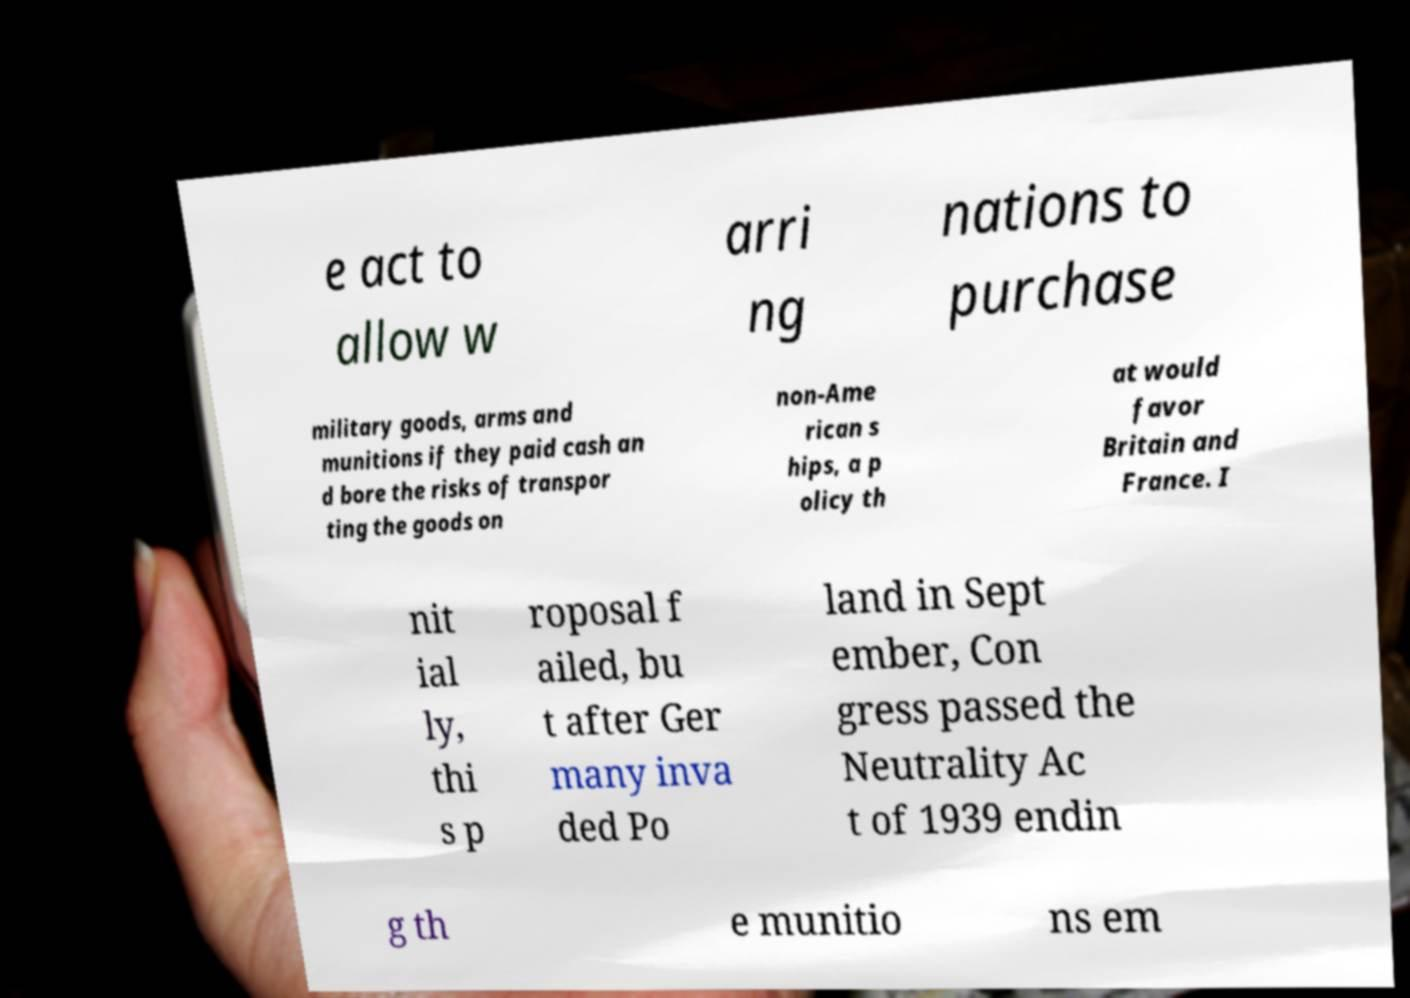Could you assist in decoding the text presented in this image and type it out clearly? e act to allow w arri ng nations to purchase military goods, arms and munitions if they paid cash an d bore the risks of transpor ting the goods on non-Ame rican s hips, a p olicy th at would favor Britain and France. I nit ial ly, thi s p roposal f ailed, bu t after Ger many inva ded Po land in Sept ember, Con gress passed the Neutrality Ac t of 1939 endin g th e munitio ns em 